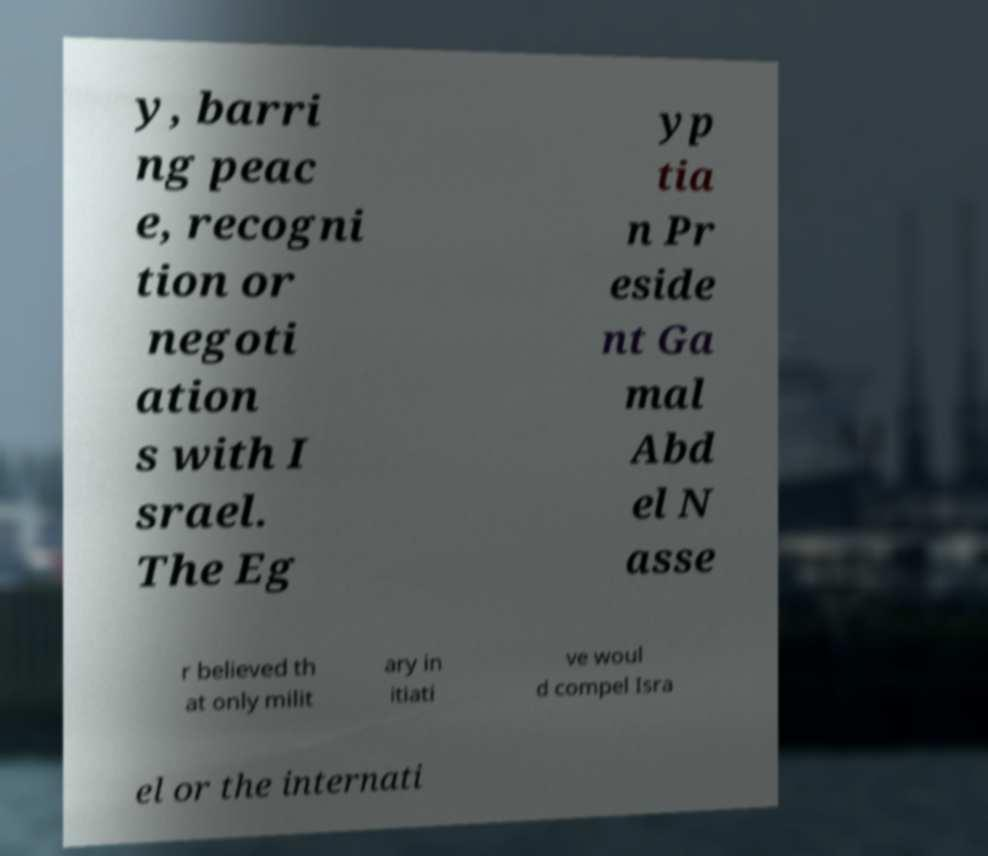I need the written content from this picture converted into text. Can you do that? y, barri ng peac e, recogni tion or negoti ation s with I srael. The Eg yp tia n Pr eside nt Ga mal Abd el N asse r believed th at only milit ary in itiati ve woul d compel Isra el or the internati 